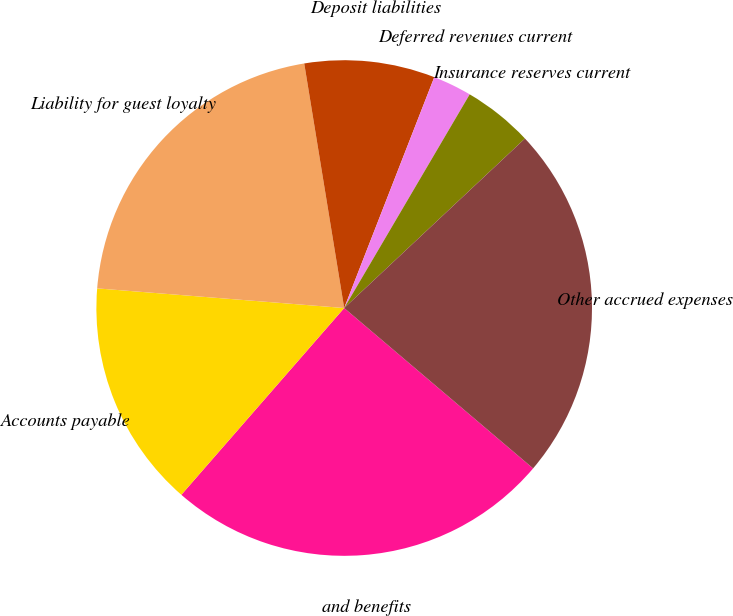<chart> <loc_0><loc_0><loc_500><loc_500><pie_chart><fcel>and benefits<fcel>Accounts payable<fcel>Liability for guest loyalty<fcel>Deposit liabilities<fcel>Deferred revenues current<fcel>Insurance reserves current<fcel>Other accrued expenses<nl><fcel>25.21%<fcel>14.85%<fcel>21.16%<fcel>8.5%<fcel>2.53%<fcel>4.56%<fcel>23.19%<nl></chart> 